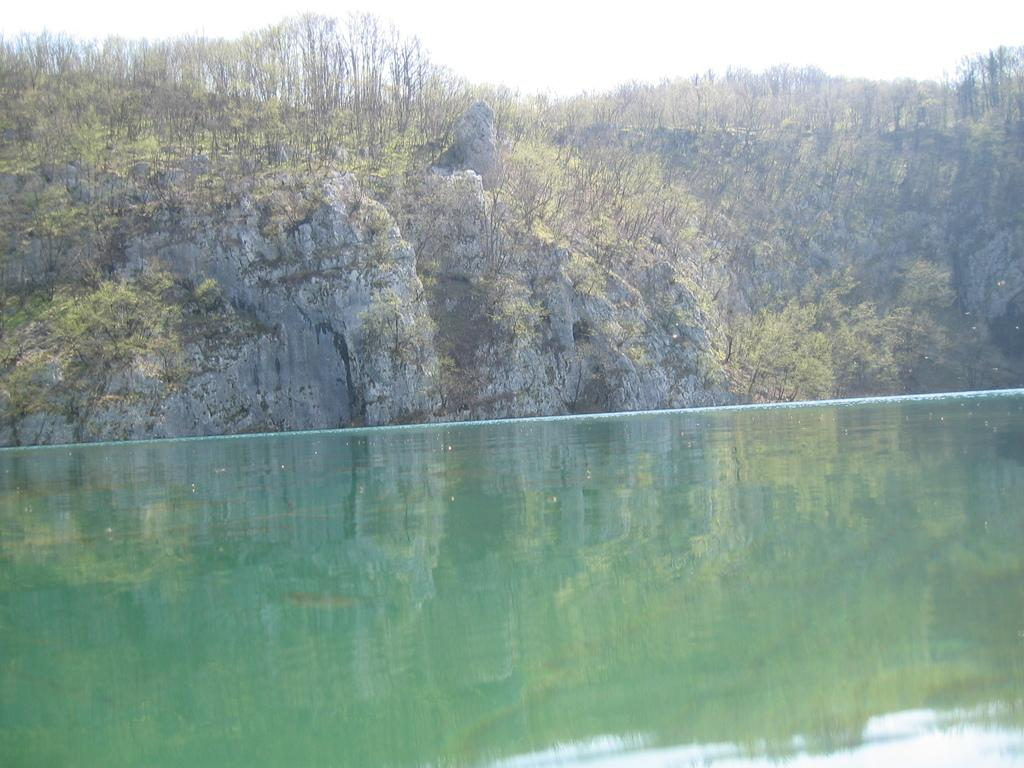What type of natural feature is present in the image? There is a river in the image. What can be seen in the distance behind the river? There is a mountain in the background of the image. How are the trees distributed on the mountain? The mountain is covered with trees. What is the condition of the sky in the image? The sky is clear in the image. What type of song is being sung by the boy in the image? There is no boy or song present in the image; it features a river and a mountain covered with trees. 